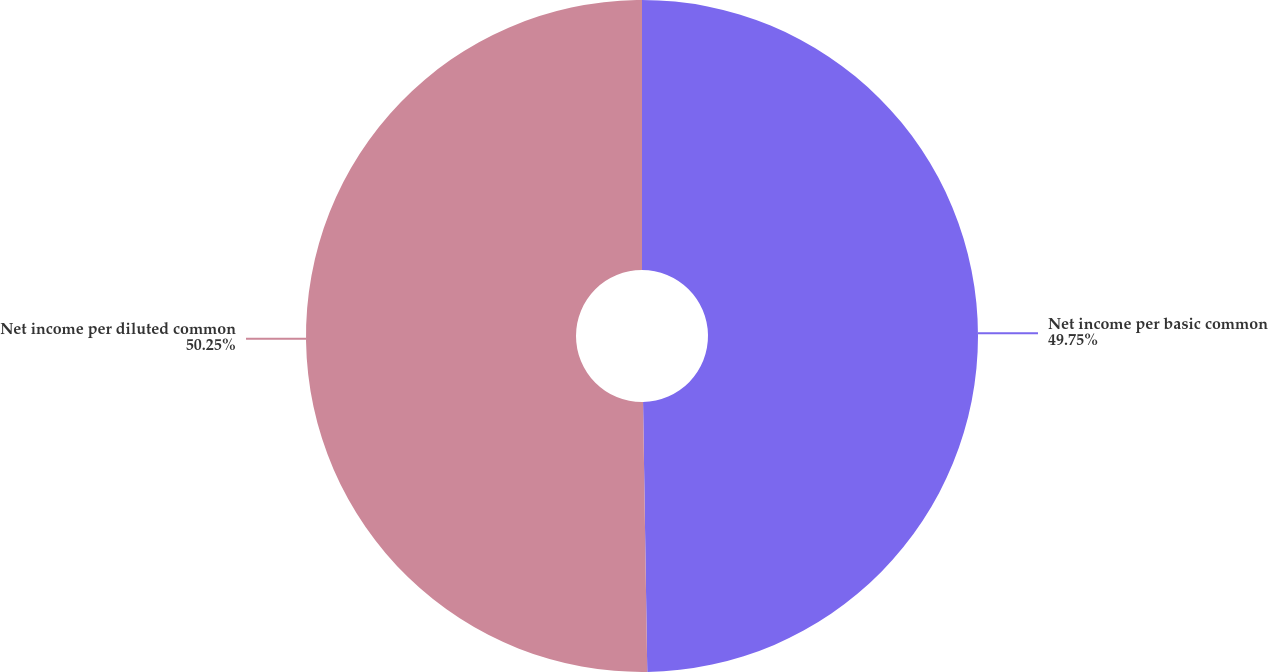Convert chart. <chart><loc_0><loc_0><loc_500><loc_500><pie_chart><fcel>Net income per basic common<fcel>Net income per diluted common<nl><fcel>49.75%<fcel>50.25%<nl></chart> 